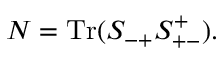Convert formula to latex. <formula><loc_0><loc_0><loc_500><loc_500>N = T r ( S _ { - + } S _ { + - } ^ { + } ) .</formula> 